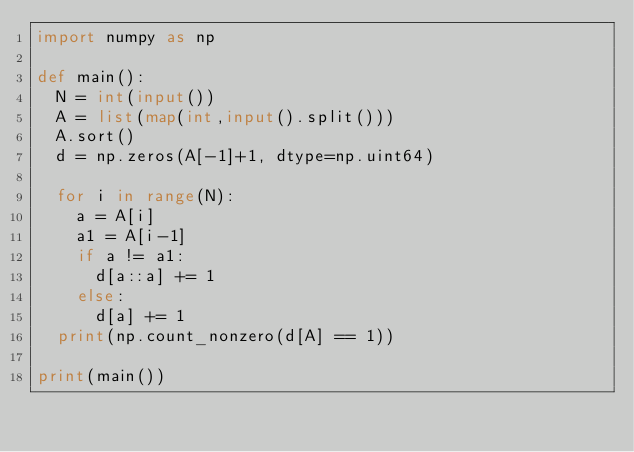Convert code to text. <code><loc_0><loc_0><loc_500><loc_500><_Python_>import numpy as np

def main():
  N = int(input())
  A = list(map(int,input().split()))
  A.sort()
  d = np.zeros(A[-1]+1, dtype=np.uint64)
  
  for i in range(N):
    a = A[i]
    a1 = A[i-1]
    if a != a1:
      d[a::a] += 1
    else:
      d[a] += 1
  print(np.count_nonzero(d[A] == 1))
  
print(main())</code> 